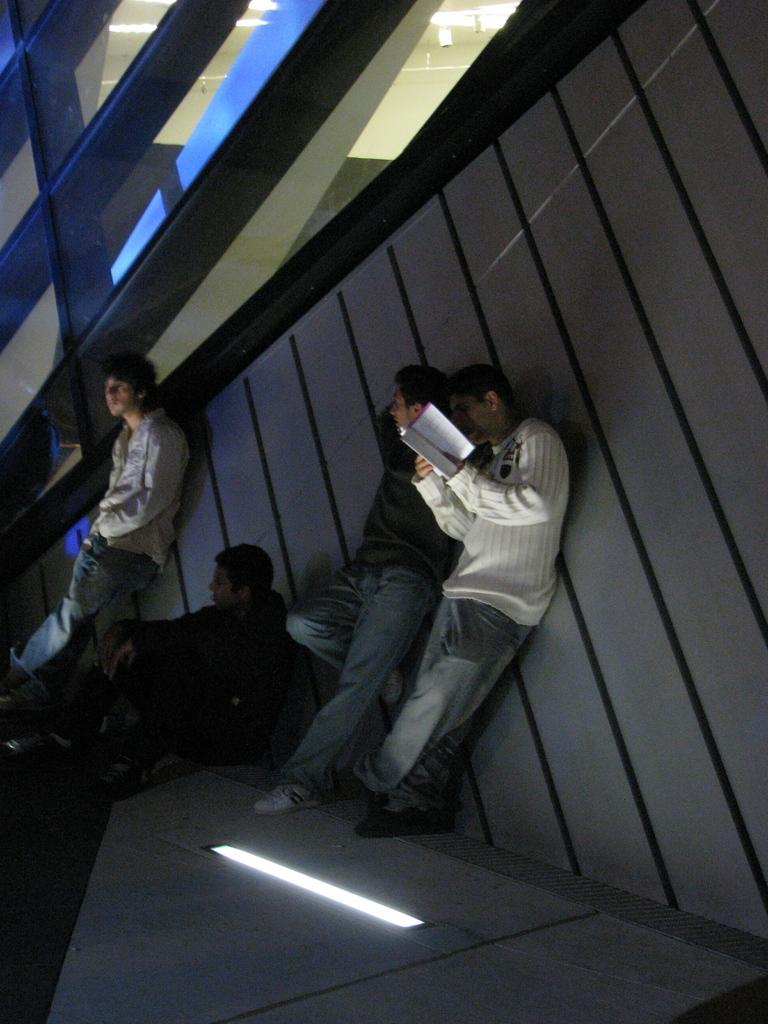How many men are present in the image? There are three men standing in the image, and one man sitting. What is the man on the right side holding? The man on the right side is holding a book. Can you describe the lighting in the image? There is a light at the bottom of the image. What type of whip is being used in the battle depicted in the image? There is no battle or whip present in the image. What kind of breakfast is being served in the image? There is no breakfast or food visible in the image. 